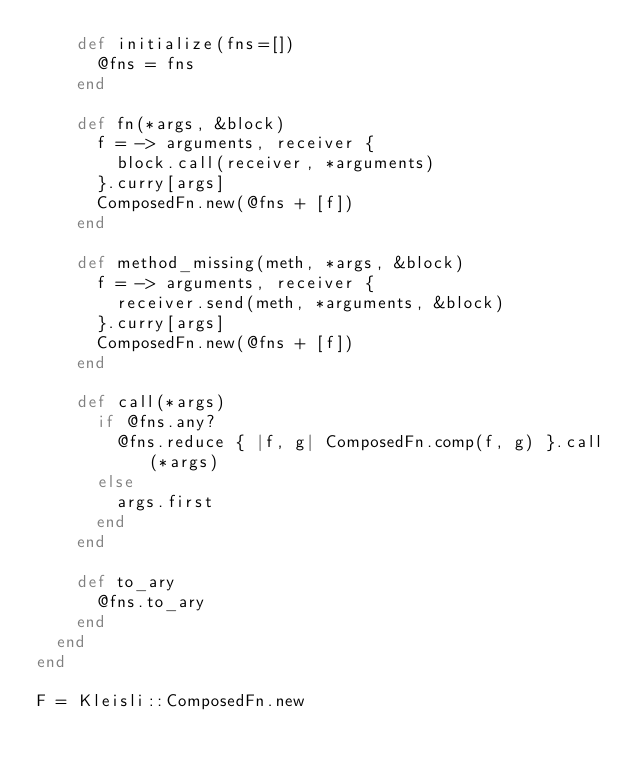Convert code to text. <code><loc_0><loc_0><loc_500><loc_500><_Ruby_>    def initialize(fns=[])
      @fns = fns
    end

    def fn(*args, &block)
      f = -> arguments, receiver {
        block.call(receiver, *arguments)
      }.curry[args]
      ComposedFn.new(@fns + [f])
    end

    def method_missing(meth, *args, &block)
      f = -> arguments, receiver {
        receiver.send(meth, *arguments, &block)
      }.curry[args]
      ComposedFn.new(@fns + [f])
    end

    def call(*args)
      if @fns.any?
        @fns.reduce { |f, g| ComposedFn.comp(f, g) }.call(*args)
      else
        args.first
      end
    end

    def to_ary
      @fns.to_ary
    end
  end
end

F = Kleisli::ComposedFn.new
</code> 